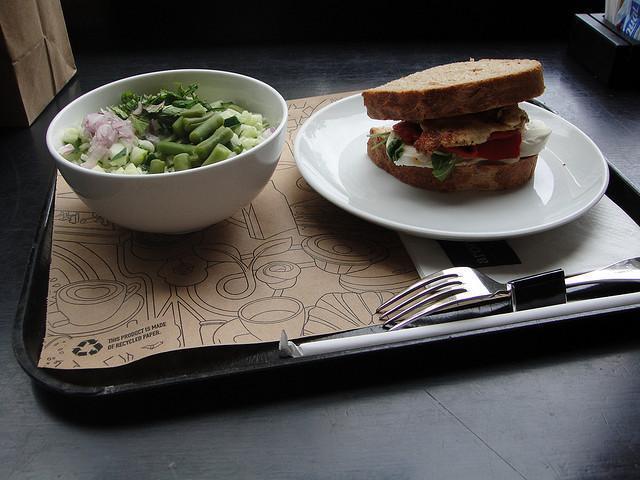How many bowls are there?
Give a very brief answer. 1. How many people are posing for a photo?
Give a very brief answer. 0. 